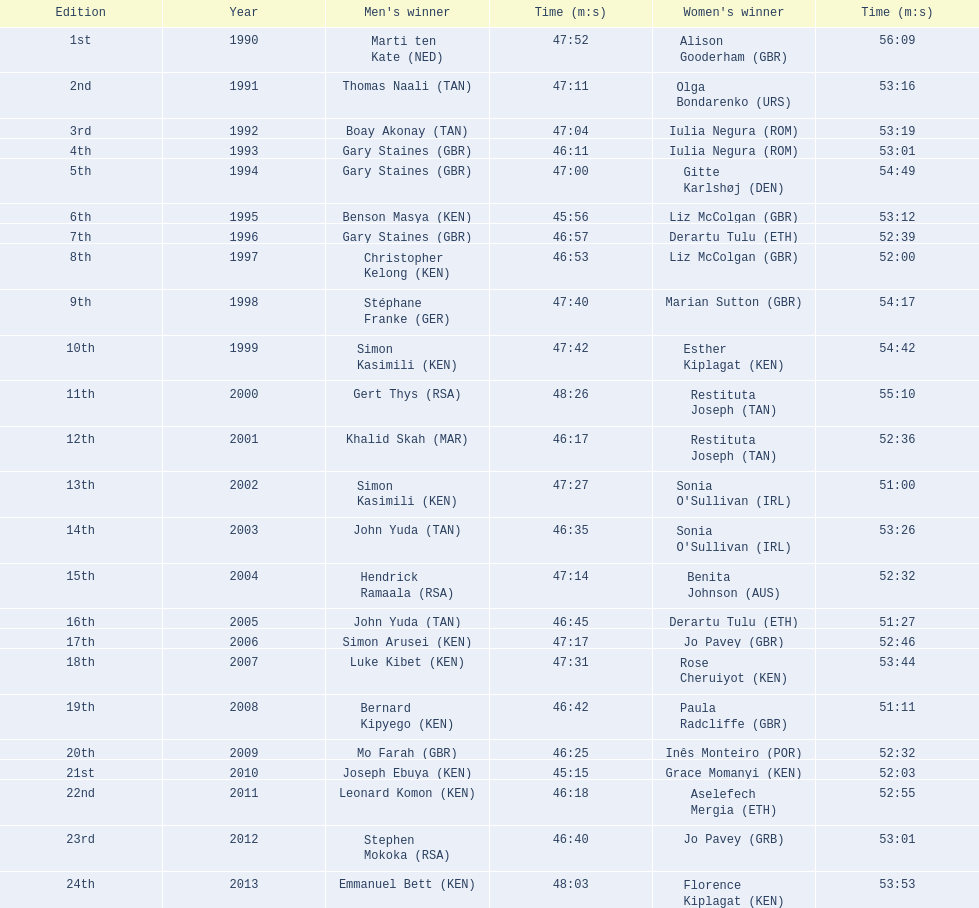In which years did the competitions take place? 1990, 1991, 1992, 1993, 1994, 1995, 1996, 1997, 1998, 1999, 2000, 2001, 2002, 2003, 2004, 2005, 2006, 2007, 2008, 2009, 2010, 2011, 2012, 2013. Who was the female champion of the 2003 event? Sonia O'Sullivan (IRL). What was her duration? 53:26. 